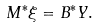Convert formula to latex. <formula><loc_0><loc_0><loc_500><loc_500>M ^ { \ast } \xi = B ^ { \ast } Y .</formula> 